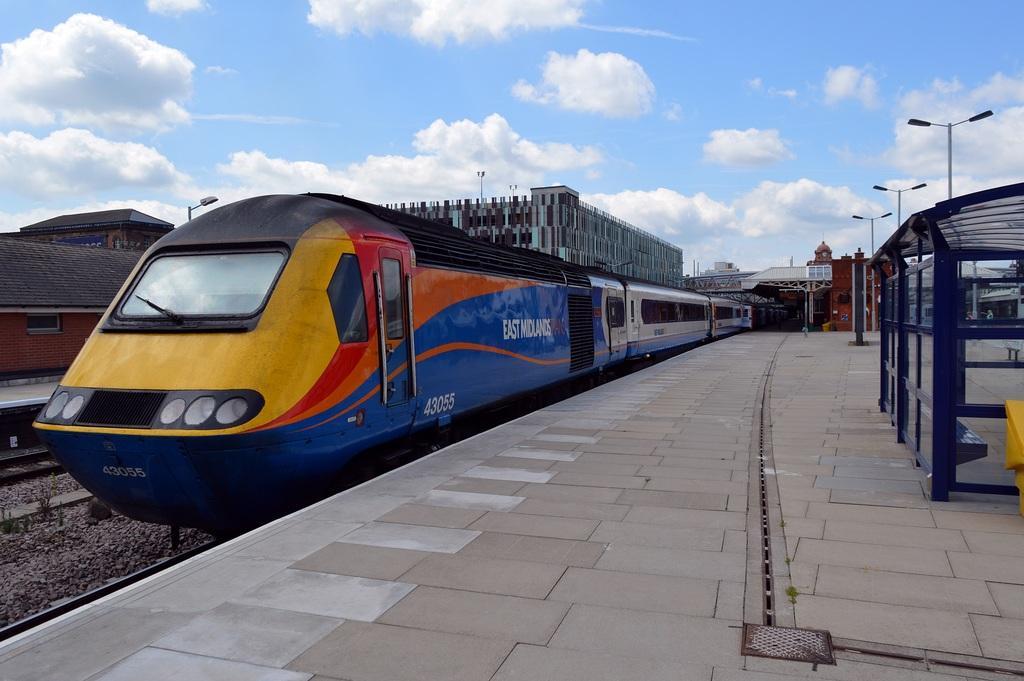Please provide a concise description of this image. In this image we can see the buildings, one house, some poles, some lights with poles, one bench, some object on the ground, some stones, one train on the railway track, some small plants and grass on the ground. At the top there is the cloudy sky. 